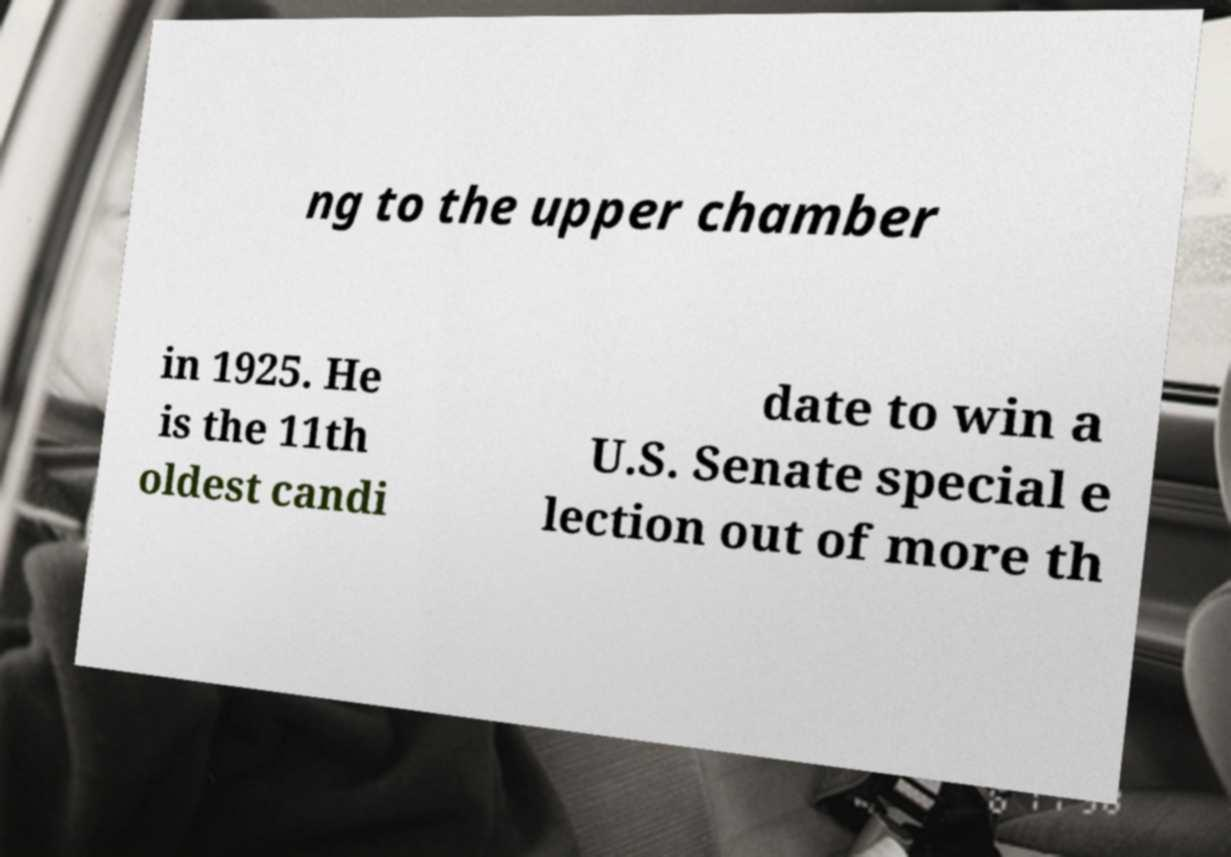There's text embedded in this image that I need extracted. Can you transcribe it verbatim? ng to the upper chamber in 1925. He is the 11th oldest candi date to win a U.S. Senate special e lection out of more th 